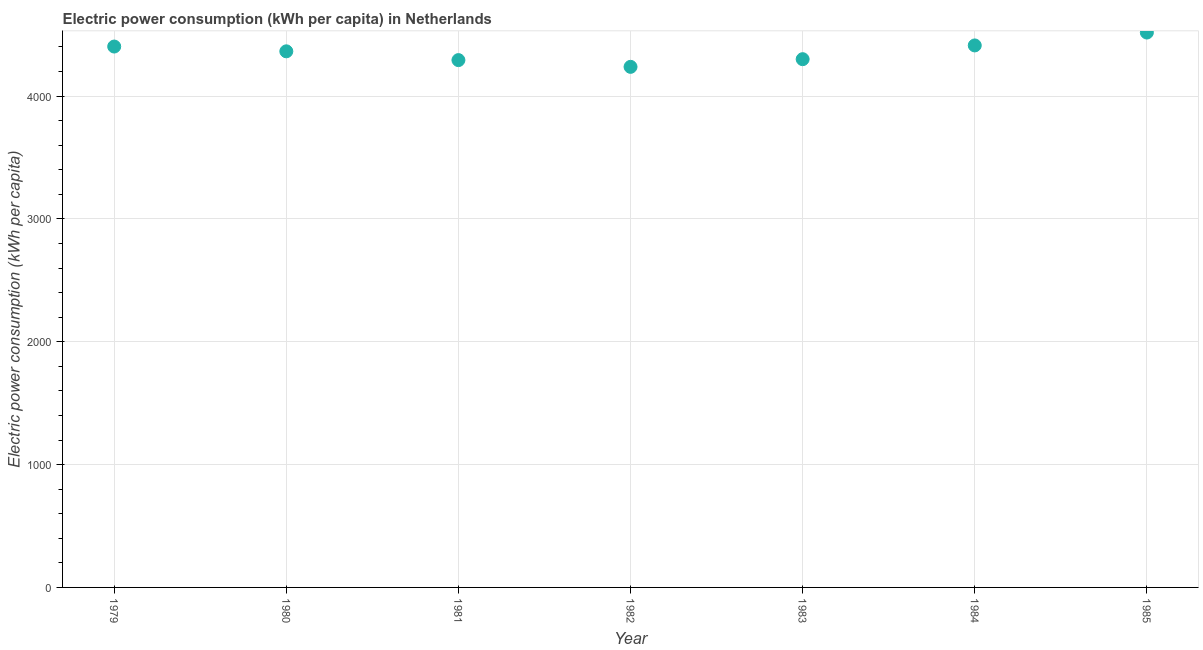What is the electric power consumption in 1985?
Ensure brevity in your answer.  4517.09. Across all years, what is the maximum electric power consumption?
Ensure brevity in your answer.  4517.09. Across all years, what is the minimum electric power consumption?
Keep it short and to the point. 4237.78. In which year was the electric power consumption maximum?
Your response must be concise. 1985. What is the sum of the electric power consumption?
Offer a terse response. 3.05e+04. What is the difference between the electric power consumption in 1979 and 1984?
Offer a very short reply. -9.06. What is the average electric power consumption per year?
Your response must be concise. 4361.04. What is the median electric power consumption?
Provide a short and direct response. 4364.16. What is the ratio of the electric power consumption in 1979 to that in 1983?
Your answer should be compact. 1.02. What is the difference between the highest and the second highest electric power consumption?
Give a very brief answer. 104.92. Is the sum of the electric power consumption in 1981 and 1984 greater than the maximum electric power consumption across all years?
Your answer should be compact. Yes. What is the difference between the highest and the lowest electric power consumption?
Offer a very short reply. 279.31. In how many years, is the electric power consumption greater than the average electric power consumption taken over all years?
Your response must be concise. 4. Does the graph contain grids?
Offer a very short reply. Yes. What is the title of the graph?
Offer a terse response. Electric power consumption (kWh per capita) in Netherlands. What is the label or title of the X-axis?
Keep it short and to the point. Year. What is the label or title of the Y-axis?
Ensure brevity in your answer.  Electric power consumption (kWh per capita). What is the Electric power consumption (kWh per capita) in 1979?
Provide a short and direct response. 4403.11. What is the Electric power consumption (kWh per capita) in 1980?
Make the answer very short. 4364.16. What is the Electric power consumption (kWh per capita) in 1981?
Your response must be concise. 4292.7. What is the Electric power consumption (kWh per capita) in 1982?
Ensure brevity in your answer.  4237.78. What is the Electric power consumption (kWh per capita) in 1983?
Provide a short and direct response. 4300.25. What is the Electric power consumption (kWh per capita) in 1984?
Ensure brevity in your answer.  4412.17. What is the Electric power consumption (kWh per capita) in 1985?
Your answer should be compact. 4517.09. What is the difference between the Electric power consumption (kWh per capita) in 1979 and 1980?
Offer a very short reply. 38.95. What is the difference between the Electric power consumption (kWh per capita) in 1979 and 1981?
Offer a very short reply. 110.41. What is the difference between the Electric power consumption (kWh per capita) in 1979 and 1982?
Give a very brief answer. 165.33. What is the difference between the Electric power consumption (kWh per capita) in 1979 and 1983?
Your response must be concise. 102.86. What is the difference between the Electric power consumption (kWh per capita) in 1979 and 1984?
Provide a short and direct response. -9.06. What is the difference between the Electric power consumption (kWh per capita) in 1979 and 1985?
Your answer should be compact. -113.98. What is the difference between the Electric power consumption (kWh per capita) in 1980 and 1981?
Offer a very short reply. 71.46. What is the difference between the Electric power consumption (kWh per capita) in 1980 and 1982?
Make the answer very short. 126.38. What is the difference between the Electric power consumption (kWh per capita) in 1980 and 1983?
Your answer should be compact. 63.91. What is the difference between the Electric power consumption (kWh per capita) in 1980 and 1984?
Your answer should be very brief. -48. What is the difference between the Electric power consumption (kWh per capita) in 1980 and 1985?
Keep it short and to the point. -152.93. What is the difference between the Electric power consumption (kWh per capita) in 1981 and 1982?
Keep it short and to the point. 54.92. What is the difference between the Electric power consumption (kWh per capita) in 1981 and 1983?
Offer a very short reply. -7.55. What is the difference between the Electric power consumption (kWh per capita) in 1981 and 1984?
Keep it short and to the point. -119.46. What is the difference between the Electric power consumption (kWh per capita) in 1981 and 1985?
Provide a succinct answer. -224.39. What is the difference between the Electric power consumption (kWh per capita) in 1982 and 1983?
Your response must be concise. -62.47. What is the difference between the Electric power consumption (kWh per capita) in 1982 and 1984?
Your answer should be compact. -174.39. What is the difference between the Electric power consumption (kWh per capita) in 1982 and 1985?
Keep it short and to the point. -279.31. What is the difference between the Electric power consumption (kWh per capita) in 1983 and 1984?
Offer a very short reply. -111.91. What is the difference between the Electric power consumption (kWh per capita) in 1983 and 1985?
Offer a very short reply. -216.84. What is the difference between the Electric power consumption (kWh per capita) in 1984 and 1985?
Your answer should be compact. -104.92. What is the ratio of the Electric power consumption (kWh per capita) in 1979 to that in 1980?
Offer a very short reply. 1.01. What is the ratio of the Electric power consumption (kWh per capita) in 1979 to that in 1981?
Your response must be concise. 1.03. What is the ratio of the Electric power consumption (kWh per capita) in 1979 to that in 1982?
Make the answer very short. 1.04. What is the ratio of the Electric power consumption (kWh per capita) in 1979 to that in 1983?
Your answer should be compact. 1.02. What is the ratio of the Electric power consumption (kWh per capita) in 1979 to that in 1985?
Give a very brief answer. 0.97. What is the ratio of the Electric power consumption (kWh per capita) in 1980 to that in 1981?
Provide a succinct answer. 1.02. What is the ratio of the Electric power consumption (kWh per capita) in 1980 to that in 1983?
Give a very brief answer. 1.01. What is the ratio of the Electric power consumption (kWh per capita) in 1981 to that in 1983?
Keep it short and to the point. 1. What is the ratio of the Electric power consumption (kWh per capita) in 1981 to that in 1984?
Offer a very short reply. 0.97. What is the ratio of the Electric power consumption (kWh per capita) in 1981 to that in 1985?
Provide a short and direct response. 0.95. What is the ratio of the Electric power consumption (kWh per capita) in 1982 to that in 1983?
Ensure brevity in your answer.  0.98. What is the ratio of the Electric power consumption (kWh per capita) in 1982 to that in 1985?
Provide a succinct answer. 0.94. What is the ratio of the Electric power consumption (kWh per capita) in 1983 to that in 1985?
Keep it short and to the point. 0.95. 